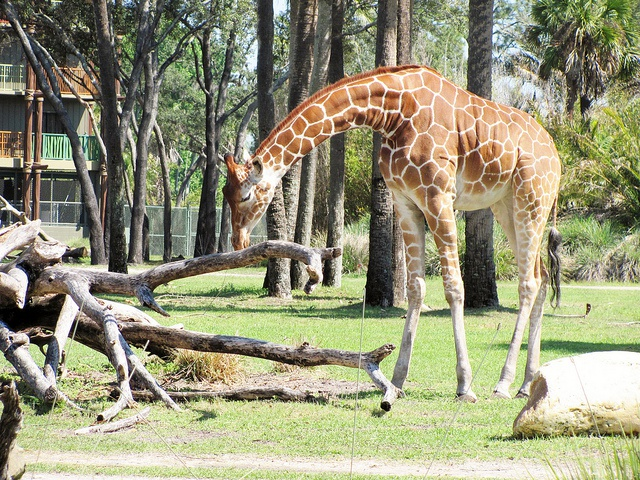Describe the objects in this image and their specific colors. I can see a giraffe in black, white, tan, and darkgray tones in this image. 